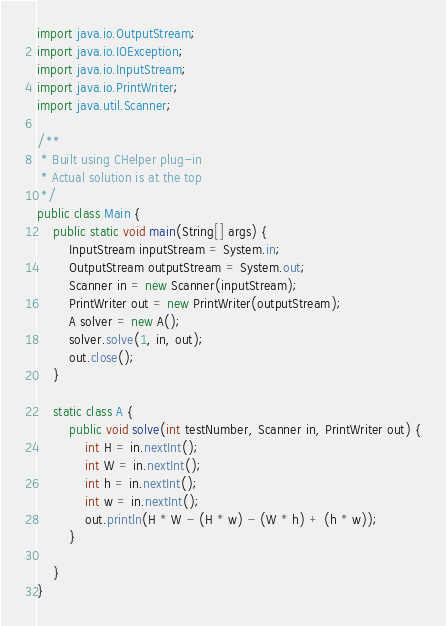<code> <loc_0><loc_0><loc_500><loc_500><_Java_>import java.io.OutputStream;
import java.io.IOException;
import java.io.InputStream;
import java.io.PrintWriter;
import java.util.Scanner;

/**
 * Built using CHelper plug-in
 * Actual solution is at the top
 */
public class Main {
    public static void main(String[] args) {
        InputStream inputStream = System.in;
        OutputStream outputStream = System.out;
        Scanner in = new Scanner(inputStream);
        PrintWriter out = new PrintWriter(outputStream);
        A solver = new A();
        solver.solve(1, in, out);
        out.close();
    }

    static class A {
        public void solve(int testNumber, Scanner in, PrintWriter out) {
            int H = in.nextInt();
            int W = in.nextInt();
            int h = in.nextInt();
            int w = in.nextInt();
            out.println(H * W - (H * w) - (W * h) + (h * w));
        }

    }
}

</code> 